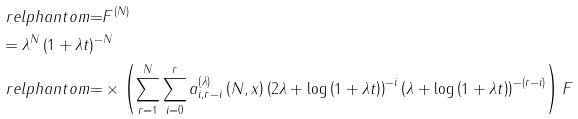<formula> <loc_0><loc_0><loc_500><loc_500>& \ r e l p h a n t o m { = } F ^ { \left ( N \right ) } \\ & = \lambda ^ { N } \left ( 1 + \lambda t \right ) ^ { - N } \\ & \ r e l p h a n t o m { = } \times \left ( \sum _ { r = 1 } ^ { N } \sum _ { i = 0 } ^ { r } a _ { i , r - i } ^ { \left ( \lambda \right ) } \left ( N , x \right ) \left ( 2 \lambda + \log \left ( 1 + \lambda t \right ) \right ) ^ { - i } \left ( \lambda + \log \left ( 1 + \lambda t \right ) \right ) ^ { - \left ( r - i \right ) } \right ) F</formula> 